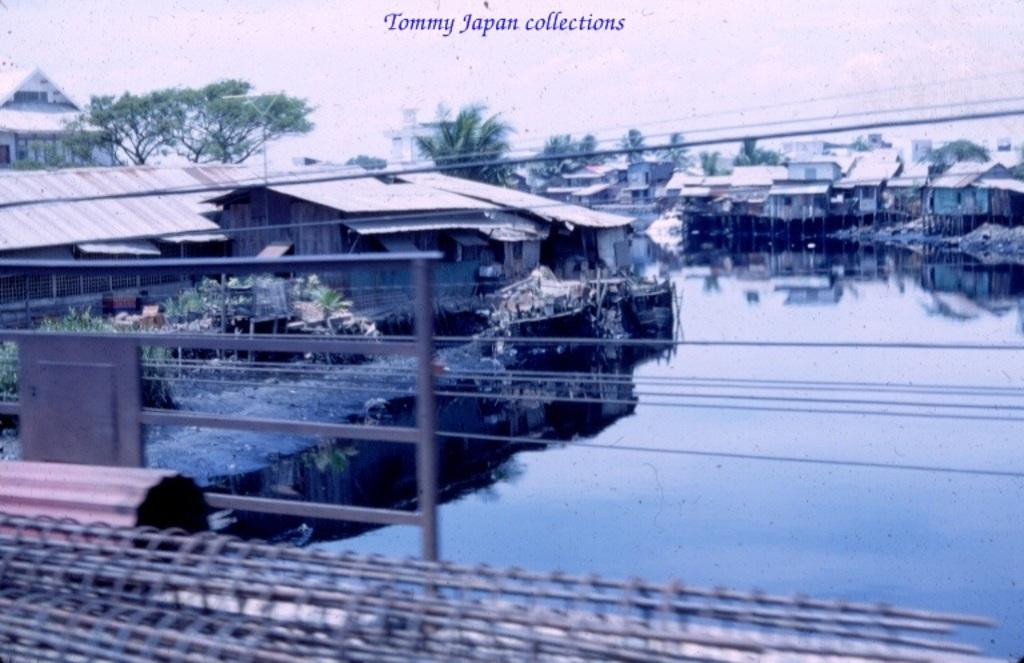What type of structure can be seen in the image? There is a grille and railing visible in the image. What natural elements are present in the image? There is water, plants, trees, and the sky visible in the image. What type of building is in the image? There is a house in the image. Is there any text or writing in the image? Yes, there is something written at the top of the image. Can you see a force being applied to the grille in the image? There is no force being applied to the grille in the image; it is a static structure. Is there a wrench visible in the image? There is no wrench present in the image. 